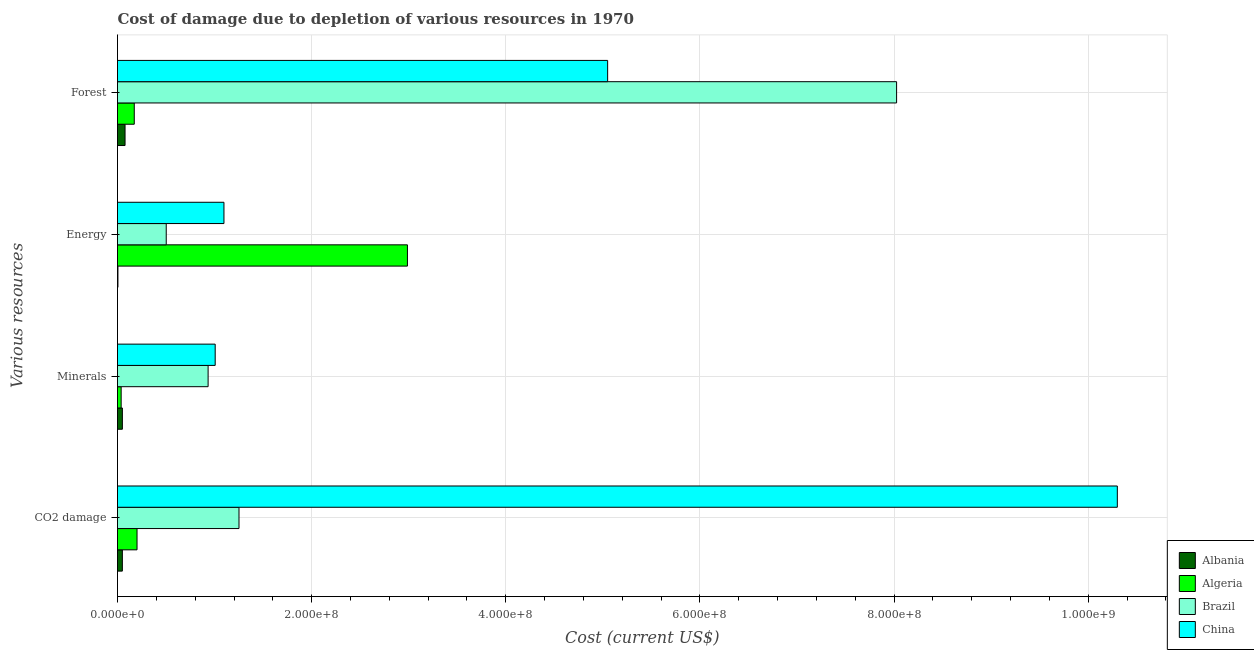How many different coloured bars are there?
Offer a very short reply. 4. How many groups of bars are there?
Ensure brevity in your answer.  4. Are the number of bars on each tick of the Y-axis equal?
Your answer should be very brief. Yes. What is the label of the 2nd group of bars from the top?
Keep it short and to the point. Energy. What is the cost of damage due to depletion of minerals in Albania?
Your response must be concise. 5.02e+06. Across all countries, what is the maximum cost of damage due to depletion of minerals?
Make the answer very short. 1.01e+08. Across all countries, what is the minimum cost of damage due to depletion of energy?
Provide a short and direct response. 4.39e+05. In which country was the cost of damage due to depletion of minerals maximum?
Your answer should be very brief. China. In which country was the cost of damage due to depletion of forests minimum?
Offer a terse response. Albania. What is the total cost of damage due to depletion of forests in the graph?
Offer a terse response. 1.33e+09. What is the difference between the cost of damage due to depletion of forests in Albania and that in Brazil?
Give a very brief answer. -7.95e+08. What is the difference between the cost of damage due to depletion of forests in Algeria and the cost of damage due to depletion of energy in Brazil?
Ensure brevity in your answer.  -3.29e+07. What is the average cost of damage due to depletion of energy per country?
Give a very brief answer. 1.15e+08. What is the difference between the cost of damage due to depletion of energy and cost of damage due to depletion of minerals in Albania?
Provide a short and direct response. -4.58e+06. What is the ratio of the cost of damage due to depletion of coal in China to that in Albania?
Ensure brevity in your answer.  206.09. Is the cost of damage due to depletion of forests in China less than that in Albania?
Your answer should be compact. No. What is the difference between the highest and the second highest cost of damage due to depletion of coal?
Give a very brief answer. 9.05e+08. What is the difference between the highest and the lowest cost of damage due to depletion of energy?
Your response must be concise. 2.98e+08. In how many countries, is the cost of damage due to depletion of minerals greater than the average cost of damage due to depletion of minerals taken over all countries?
Your answer should be compact. 2. What does the 2nd bar from the top in Energy represents?
Your answer should be very brief. Brazil. What does the 3rd bar from the bottom in Forest represents?
Your response must be concise. Brazil. Is it the case that in every country, the sum of the cost of damage due to depletion of coal and cost of damage due to depletion of minerals is greater than the cost of damage due to depletion of energy?
Ensure brevity in your answer.  No. What is the difference between two consecutive major ticks on the X-axis?
Provide a short and direct response. 2.00e+08. Does the graph contain grids?
Your answer should be compact. Yes. What is the title of the graph?
Your response must be concise. Cost of damage due to depletion of various resources in 1970 . Does "Brazil" appear as one of the legend labels in the graph?
Your response must be concise. Yes. What is the label or title of the X-axis?
Your answer should be compact. Cost (current US$). What is the label or title of the Y-axis?
Ensure brevity in your answer.  Various resources. What is the Cost (current US$) of Albania in CO2 damage?
Offer a very short reply. 5.00e+06. What is the Cost (current US$) of Algeria in CO2 damage?
Give a very brief answer. 2.01e+07. What is the Cost (current US$) in Brazil in CO2 damage?
Keep it short and to the point. 1.25e+08. What is the Cost (current US$) in China in CO2 damage?
Provide a short and direct response. 1.03e+09. What is the Cost (current US$) of Albania in Minerals?
Provide a short and direct response. 5.02e+06. What is the Cost (current US$) of Algeria in Minerals?
Offer a terse response. 3.76e+06. What is the Cost (current US$) in Brazil in Minerals?
Make the answer very short. 9.33e+07. What is the Cost (current US$) of China in Minerals?
Your answer should be compact. 1.01e+08. What is the Cost (current US$) of Albania in Energy?
Make the answer very short. 4.39e+05. What is the Cost (current US$) in Algeria in Energy?
Make the answer very short. 2.99e+08. What is the Cost (current US$) of Brazil in Energy?
Ensure brevity in your answer.  5.02e+07. What is the Cost (current US$) in China in Energy?
Your answer should be compact. 1.10e+08. What is the Cost (current US$) of Albania in Forest?
Your response must be concise. 7.78e+06. What is the Cost (current US$) of Algeria in Forest?
Offer a terse response. 1.73e+07. What is the Cost (current US$) of Brazil in Forest?
Offer a very short reply. 8.03e+08. What is the Cost (current US$) in China in Forest?
Offer a very short reply. 5.05e+08. Across all Various resources, what is the maximum Cost (current US$) in Albania?
Make the answer very short. 7.78e+06. Across all Various resources, what is the maximum Cost (current US$) in Algeria?
Your answer should be compact. 2.99e+08. Across all Various resources, what is the maximum Cost (current US$) of Brazil?
Make the answer very short. 8.03e+08. Across all Various resources, what is the maximum Cost (current US$) in China?
Give a very brief answer. 1.03e+09. Across all Various resources, what is the minimum Cost (current US$) of Albania?
Keep it short and to the point. 4.39e+05. Across all Various resources, what is the minimum Cost (current US$) of Algeria?
Ensure brevity in your answer.  3.76e+06. Across all Various resources, what is the minimum Cost (current US$) in Brazil?
Provide a succinct answer. 5.02e+07. Across all Various resources, what is the minimum Cost (current US$) in China?
Give a very brief answer. 1.01e+08. What is the total Cost (current US$) of Albania in the graph?
Provide a short and direct response. 1.82e+07. What is the total Cost (current US$) in Algeria in the graph?
Offer a terse response. 3.40e+08. What is the total Cost (current US$) of Brazil in the graph?
Ensure brevity in your answer.  1.07e+09. What is the total Cost (current US$) in China in the graph?
Provide a short and direct response. 1.75e+09. What is the difference between the Cost (current US$) of Albania in CO2 damage and that in Minerals?
Ensure brevity in your answer.  -2.17e+04. What is the difference between the Cost (current US$) of Algeria in CO2 damage and that in Minerals?
Offer a terse response. 1.64e+07. What is the difference between the Cost (current US$) of Brazil in CO2 damage and that in Minerals?
Your answer should be compact. 3.18e+07. What is the difference between the Cost (current US$) in China in CO2 damage and that in Minerals?
Make the answer very short. 9.29e+08. What is the difference between the Cost (current US$) in Albania in CO2 damage and that in Energy?
Your response must be concise. 4.56e+06. What is the difference between the Cost (current US$) of Algeria in CO2 damage and that in Energy?
Provide a short and direct response. -2.79e+08. What is the difference between the Cost (current US$) in Brazil in CO2 damage and that in Energy?
Keep it short and to the point. 7.50e+07. What is the difference between the Cost (current US$) of China in CO2 damage and that in Energy?
Your answer should be compact. 9.20e+08. What is the difference between the Cost (current US$) of Albania in CO2 damage and that in Forest?
Ensure brevity in your answer.  -2.78e+06. What is the difference between the Cost (current US$) in Algeria in CO2 damage and that in Forest?
Give a very brief answer. 2.85e+06. What is the difference between the Cost (current US$) of Brazil in CO2 damage and that in Forest?
Provide a succinct answer. -6.77e+08. What is the difference between the Cost (current US$) of China in CO2 damage and that in Forest?
Your response must be concise. 5.25e+08. What is the difference between the Cost (current US$) of Albania in Minerals and that in Energy?
Give a very brief answer. 4.58e+06. What is the difference between the Cost (current US$) of Algeria in Minerals and that in Energy?
Provide a short and direct response. -2.95e+08. What is the difference between the Cost (current US$) in Brazil in Minerals and that in Energy?
Offer a very short reply. 4.31e+07. What is the difference between the Cost (current US$) of China in Minerals and that in Energy?
Ensure brevity in your answer.  -9.02e+06. What is the difference between the Cost (current US$) in Albania in Minerals and that in Forest?
Offer a very short reply. -2.76e+06. What is the difference between the Cost (current US$) in Algeria in Minerals and that in Forest?
Keep it short and to the point. -1.35e+07. What is the difference between the Cost (current US$) of Brazil in Minerals and that in Forest?
Give a very brief answer. -7.09e+08. What is the difference between the Cost (current US$) of China in Minerals and that in Forest?
Ensure brevity in your answer.  -4.04e+08. What is the difference between the Cost (current US$) in Albania in Energy and that in Forest?
Your answer should be compact. -7.34e+06. What is the difference between the Cost (current US$) of Algeria in Energy and that in Forest?
Keep it short and to the point. 2.81e+08. What is the difference between the Cost (current US$) of Brazil in Energy and that in Forest?
Your response must be concise. -7.52e+08. What is the difference between the Cost (current US$) of China in Energy and that in Forest?
Ensure brevity in your answer.  -3.95e+08. What is the difference between the Cost (current US$) in Albania in CO2 damage and the Cost (current US$) in Algeria in Minerals?
Give a very brief answer. 1.24e+06. What is the difference between the Cost (current US$) of Albania in CO2 damage and the Cost (current US$) of Brazil in Minerals?
Your answer should be compact. -8.83e+07. What is the difference between the Cost (current US$) in Albania in CO2 damage and the Cost (current US$) in China in Minerals?
Ensure brevity in your answer.  -9.56e+07. What is the difference between the Cost (current US$) of Algeria in CO2 damage and the Cost (current US$) of Brazil in Minerals?
Ensure brevity in your answer.  -7.32e+07. What is the difference between the Cost (current US$) in Algeria in CO2 damage and the Cost (current US$) in China in Minerals?
Your answer should be compact. -8.05e+07. What is the difference between the Cost (current US$) of Brazil in CO2 damage and the Cost (current US$) of China in Minerals?
Keep it short and to the point. 2.45e+07. What is the difference between the Cost (current US$) in Albania in CO2 damage and the Cost (current US$) in Algeria in Energy?
Ensure brevity in your answer.  -2.94e+08. What is the difference between the Cost (current US$) of Albania in CO2 damage and the Cost (current US$) of Brazil in Energy?
Provide a short and direct response. -4.52e+07. What is the difference between the Cost (current US$) of Albania in CO2 damage and the Cost (current US$) of China in Energy?
Give a very brief answer. -1.05e+08. What is the difference between the Cost (current US$) of Algeria in CO2 damage and the Cost (current US$) of Brazil in Energy?
Your answer should be very brief. -3.01e+07. What is the difference between the Cost (current US$) in Algeria in CO2 damage and the Cost (current US$) in China in Energy?
Your answer should be very brief. -8.95e+07. What is the difference between the Cost (current US$) of Brazil in CO2 damage and the Cost (current US$) of China in Energy?
Ensure brevity in your answer.  1.55e+07. What is the difference between the Cost (current US$) of Albania in CO2 damage and the Cost (current US$) of Algeria in Forest?
Make the answer very short. -1.23e+07. What is the difference between the Cost (current US$) in Albania in CO2 damage and the Cost (current US$) in Brazil in Forest?
Give a very brief answer. -7.98e+08. What is the difference between the Cost (current US$) of Albania in CO2 damage and the Cost (current US$) of China in Forest?
Ensure brevity in your answer.  -5.00e+08. What is the difference between the Cost (current US$) of Algeria in CO2 damage and the Cost (current US$) of Brazil in Forest?
Provide a succinct answer. -7.82e+08. What is the difference between the Cost (current US$) of Algeria in CO2 damage and the Cost (current US$) of China in Forest?
Offer a very short reply. -4.85e+08. What is the difference between the Cost (current US$) of Brazil in CO2 damage and the Cost (current US$) of China in Forest?
Your answer should be very brief. -3.80e+08. What is the difference between the Cost (current US$) in Albania in Minerals and the Cost (current US$) in Algeria in Energy?
Give a very brief answer. -2.94e+08. What is the difference between the Cost (current US$) of Albania in Minerals and the Cost (current US$) of Brazil in Energy?
Your response must be concise. -4.52e+07. What is the difference between the Cost (current US$) in Albania in Minerals and the Cost (current US$) in China in Energy?
Give a very brief answer. -1.05e+08. What is the difference between the Cost (current US$) of Algeria in Minerals and the Cost (current US$) of Brazil in Energy?
Offer a very short reply. -4.64e+07. What is the difference between the Cost (current US$) in Algeria in Minerals and the Cost (current US$) in China in Energy?
Give a very brief answer. -1.06e+08. What is the difference between the Cost (current US$) in Brazil in Minerals and the Cost (current US$) in China in Energy?
Offer a very short reply. -1.63e+07. What is the difference between the Cost (current US$) of Albania in Minerals and the Cost (current US$) of Algeria in Forest?
Provide a short and direct response. -1.23e+07. What is the difference between the Cost (current US$) in Albania in Minerals and the Cost (current US$) in Brazil in Forest?
Offer a terse response. -7.98e+08. What is the difference between the Cost (current US$) of Albania in Minerals and the Cost (current US$) of China in Forest?
Ensure brevity in your answer.  -5.00e+08. What is the difference between the Cost (current US$) of Algeria in Minerals and the Cost (current US$) of Brazil in Forest?
Make the answer very short. -7.99e+08. What is the difference between the Cost (current US$) of Algeria in Minerals and the Cost (current US$) of China in Forest?
Ensure brevity in your answer.  -5.01e+08. What is the difference between the Cost (current US$) of Brazil in Minerals and the Cost (current US$) of China in Forest?
Your answer should be compact. -4.12e+08. What is the difference between the Cost (current US$) of Albania in Energy and the Cost (current US$) of Algeria in Forest?
Your answer should be compact. -1.68e+07. What is the difference between the Cost (current US$) of Albania in Energy and the Cost (current US$) of Brazil in Forest?
Your answer should be compact. -8.02e+08. What is the difference between the Cost (current US$) in Albania in Energy and the Cost (current US$) in China in Forest?
Your response must be concise. -5.04e+08. What is the difference between the Cost (current US$) in Algeria in Energy and the Cost (current US$) in Brazil in Forest?
Keep it short and to the point. -5.04e+08. What is the difference between the Cost (current US$) of Algeria in Energy and the Cost (current US$) of China in Forest?
Your response must be concise. -2.06e+08. What is the difference between the Cost (current US$) in Brazil in Energy and the Cost (current US$) in China in Forest?
Provide a short and direct response. -4.55e+08. What is the average Cost (current US$) of Albania per Various resources?
Offer a very short reply. 4.56e+06. What is the average Cost (current US$) of Algeria per Various resources?
Offer a very short reply. 8.50e+07. What is the average Cost (current US$) in Brazil per Various resources?
Give a very brief answer. 2.68e+08. What is the average Cost (current US$) of China per Various resources?
Your response must be concise. 4.36e+08. What is the difference between the Cost (current US$) in Albania and Cost (current US$) in Algeria in CO2 damage?
Ensure brevity in your answer.  -1.51e+07. What is the difference between the Cost (current US$) in Albania and Cost (current US$) in Brazil in CO2 damage?
Your response must be concise. -1.20e+08. What is the difference between the Cost (current US$) of Albania and Cost (current US$) of China in CO2 damage?
Offer a very short reply. -1.02e+09. What is the difference between the Cost (current US$) in Algeria and Cost (current US$) in Brazil in CO2 damage?
Provide a succinct answer. -1.05e+08. What is the difference between the Cost (current US$) in Algeria and Cost (current US$) in China in CO2 damage?
Offer a very short reply. -1.01e+09. What is the difference between the Cost (current US$) in Brazil and Cost (current US$) in China in CO2 damage?
Your answer should be compact. -9.05e+08. What is the difference between the Cost (current US$) in Albania and Cost (current US$) in Algeria in Minerals?
Offer a very short reply. 1.26e+06. What is the difference between the Cost (current US$) in Albania and Cost (current US$) in Brazil in Minerals?
Offer a terse response. -8.83e+07. What is the difference between the Cost (current US$) in Albania and Cost (current US$) in China in Minerals?
Provide a succinct answer. -9.56e+07. What is the difference between the Cost (current US$) in Algeria and Cost (current US$) in Brazil in Minerals?
Offer a terse response. -8.96e+07. What is the difference between the Cost (current US$) of Algeria and Cost (current US$) of China in Minerals?
Ensure brevity in your answer.  -9.69e+07. What is the difference between the Cost (current US$) in Brazil and Cost (current US$) in China in Minerals?
Offer a very short reply. -7.30e+06. What is the difference between the Cost (current US$) in Albania and Cost (current US$) in Algeria in Energy?
Keep it short and to the point. -2.98e+08. What is the difference between the Cost (current US$) of Albania and Cost (current US$) of Brazil in Energy?
Your answer should be compact. -4.98e+07. What is the difference between the Cost (current US$) in Albania and Cost (current US$) in China in Energy?
Make the answer very short. -1.09e+08. What is the difference between the Cost (current US$) in Algeria and Cost (current US$) in Brazil in Energy?
Make the answer very short. 2.48e+08. What is the difference between the Cost (current US$) of Algeria and Cost (current US$) of China in Energy?
Ensure brevity in your answer.  1.89e+08. What is the difference between the Cost (current US$) in Brazil and Cost (current US$) in China in Energy?
Ensure brevity in your answer.  -5.95e+07. What is the difference between the Cost (current US$) in Albania and Cost (current US$) in Algeria in Forest?
Your answer should be compact. -9.50e+06. What is the difference between the Cost (current US$) in Albania and Cost (current US$) in Brazil in Forest?
Offer a very short reply. -7.95e+08. What is the difference between the Cost (current US$) of Albania and Cost (current US$) of China in Forest?
Keep it short and to the point. -4.97e+08. What is the difference between the Cost (current US$) in Algeria and Cost (current US$) in Brazil in Forest?
Your answer should be compact. -7.85e+08. What is the difference between the Cost (current US$) of Algeria and Cost (current US$) of China in Forest?
Ensure brevity in your answer.  -4.88e+08. What is the difference between the Cost (current US$) of Brazil and Cost (current US$) of China in Forest?
Your response must be concise. 2.98e+08. What is the ratio of the Cost (current US$) in Algeria in CO2 damage to that in Minerals?
Your answer should be very brief. 5.35. What is the ratio of the Cost (current US$) of Brazil in CO2 damage to that in Minerals?
Offer a very short reply. 1.34. What is the ratio of the Cost (current US$) in China in CO2 damage to that in Minerals?
Provide a short and direct response. 10.23. What is the ratio of the Cost (current US$) of Albania in CO2 damage to that in Energy?
Provide a succinct answer. 11.39. What is the ratio of the Cost (current US$) in Algeria in CO2 damage to that in Energy?
Your response must be concise. 0.07. What is the ratio of the Cost (current US$) of Brazil in CO2 damage to that in Energy?
Offer a terse response. 2.49. What is the ratio of the Cost (current US$) of China in CO2 damage to that in Energy?
Make the answer very short. 9.39. What is the ratio of the Cost (current US$) in Albania in CO2 damage to that in Forest?
Your answer should be compact. 0.64. What is the ratio of the Cost (current US$) in Algeria in CO2 damage to that in Forest?
Give a very brief answer. 1.17. What is the ratio of the Cost (current US$) in Brazil in CO2 damage to that in Forest?
Your answer should be compact. 0.16. What is the ratio of the Cost (current US$) of China in CO2 damage to that in Forest?
Give a very brief answer. 2.04. What is the ratio of the Cost (current US$) in Albania in Minerals to that in Energy?
Ensure brevity in your answer.  11.44. What is the ratio of the Cost (current US$) of Algeria in Minerals to that in Energy?
Offer a terse response. 0.01. What is the ratio of the Cost (current US$) in Brazil in Minerals to that in Energy?
Give a very brief answer. 1.86. What is the ratio of the Cost (current US$) in China in Minerals to that in Energy?
Offer a very short reply. 0.92. What is the ratio of the Cost (current US$) in Albania in Minerals to that in Forest?
Make the answer very short. 0.65. What is the ratio of the Cost (current US$) of Algeria in Minerals to that in Forest?
Your response must be concise. 0.22. What is the ratio of the Cost (current US$) in Brazil in Minerals to that in Forest?
Provide a succinct answer. 0.12. What is the ratio of the Cost (current US$) of China in Minerals to that in Forest?
Provide a succinct answer. 0.2. What is the ratio of the Cost (current US$) in Albania in Energy to that in Forest?
Your response must be concise. 0.06. What is the ratio of the Cost (current US$) of Algeria in Energy to that in Forest?
Offer a very short reply. 17.29. What is the ratio of the Cost (current US$) of Brazil in Energy to that in Forest?
Provide a short and direct response. 0.06. What is the ratio of the Cost (current US$) in China in Energy to that in Forest?
Offer a terse response. 0.22. What is the difference between the highest and the second highest Cost (current US$) of Albania?
Give a very brief answer. 2.76e+06. What is the difference between the highest and the second highest Cost (current US$) of Algeria?
Provide a succinct answer. 2.79e+08. What is the difference between the highest and the second highest Cost (current US$) in Brazil?
Your answer should be compact. 6.77e+08. What is the difference between the highest and the second highest Cost (current US$) in China?
Make the answer very short. 5.25e+08. What is the difference between the highest and the lowest Cost (current US$) in Albania?
Provide a short and direct response. 7.34e+06. What is the difference between the highest and the lowest Cost (current US$) of Algeria?
Keep it short and to the point. 2.95e+08. What is the difference between the highest and the lowest Cost (current US$) in Brazil?
Offer a very short reply. 7.52e+08. What is the difference between the highest and the lowest Cost (current US$) in China?
Offer a very short reply. 9.29e+08. 